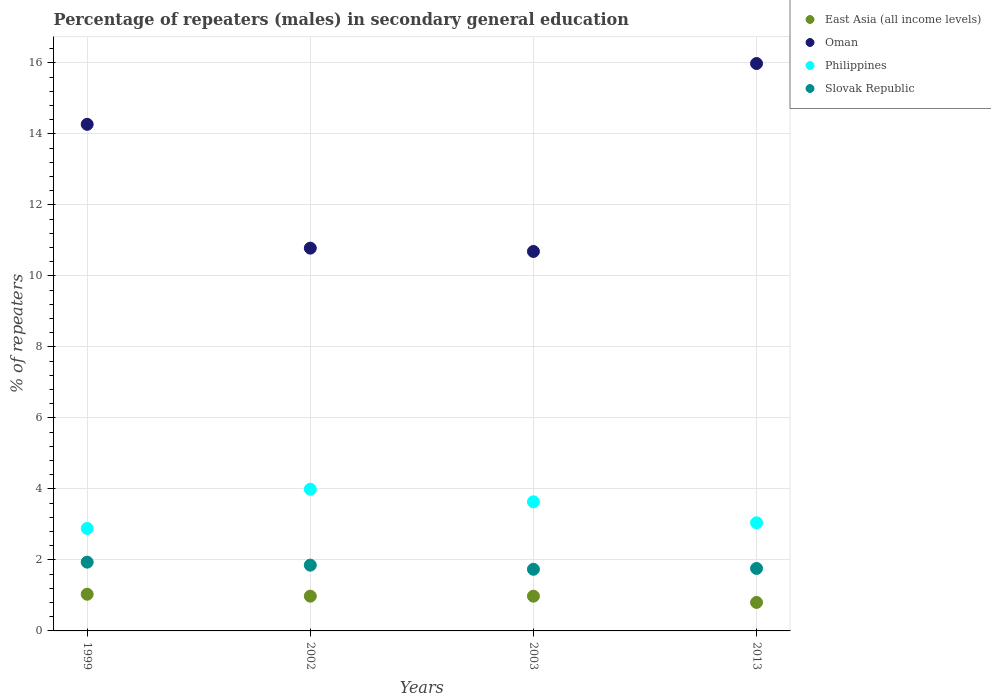How many different coloured dotlines are there?
Provide a short and direct response. 4. What is the percentage of male repeaters in Oman in 2013?
Provide a short and direct response. 15.98. Across all years, what is the maximum percentage of male repeaters in East Asia (all income levels)?
Provide a short and direct response. 1.03. Across all years, what is the minimum percentage of male repeaters in Philippines?
Ensure brevity in your answer.  2.89. In which year was the percentage of male repeaters in Oman maximum?
Your response must be concise. 2013. What is the total percentage of male repeaters in East Asia (all income levels) in the graph?
Your response must be concise. 3.79. What is the difference between the percentage of male repeaters in Oman in 1999 and that in 2013?
Provide a succinct answer. -1.71. What is the difference between the percentage of male repeaters in Philippines in 2003 and the percentage of male repeaters in Oman in 2013?
Your answer should be very brief. -12.34. What is the average percentage of male repeaters in Slovak Republic per year?
Give a very brief answer. 1.82. In the year 1999, what is the difference between the percentage of male repeaters in Philippines and percentage of male repeaters in Oman?
Offer a terse response. -11.38. In how many years, is the percentage of male repeaters in Oman greater than 3.6 %?
Ensure brevity in your answer.  4. What is the ratio of the percentage of male repeaters in Philippines in 2002 to that in 2013?
Offer a terse response. 1.31. Is the percentage of male repeaters in Philippines in 1999 less than that in 2013?
Keep it short and to the point. Yes. Is the difference between the percentage of male repeaters in Philippines in 2002 and 2003 greater than the difference between the percentage of male repeaters in Oman in 2002 and 2003?
Keep it short and to the point. Yes. What is the difference between the highest and the second highest percentage of male repeaters in Philippines?
Make the answer very short. 0.36. What is the difference between the highest and the lowest percentage of male repeaters in Oman?
Provide a short and direct response. 5.29. Is the sum of the percentage of male repeaters in Oman in 1999 and 2002 greater than the maximum percentage of male repeaters in Philippines across all years?
Offer a terse response. Yes. Is it the case that in every year, the sum of the percentage of male repeaters in Philippines and percentage of male repeaters in Oman  is greater than the sum of percentage of male repeaters in East Asia (all income levels) and percentage of male repeaters in Slovak Republic?
Provide a short and direct response. No. Is the percentage of male repeaters in East Asia (all income levels) strictly less than the percentage of male repeaters in Philippines over the years?
Provide a succinct answer. Yes. What is the difference between two consecutive major ticks on the Y-axis?
Offer a terse response. 2. Does the graph contain any zero values?
Your response must be concise. No. How many legend labels are there?
Offer a terse response. 4. What is the title of the graph?
Offer a very short reply. Percentage of repeaters (males) in secondary general education. Does "Albania" appear as one of the legend labels in the graph?
Your response must be concise. No. What is the label or title of the X-axis?
Provide a short and direct response. Years. What is the label or title of the Y-axis?
Offer a terse response. % of repeaters. What is the % of repeaters in East Asia (all income levels) in 1999?
Your answer should be compact. 1.03. What is the % of repeaters in Oman in 1999?
Your response must be concise. 14.27. What is the % of repeaters of Philippines in 1999?
Give a very brief answer. 2.89. What is the % of repeaters of Slovak Republic in 1999?
Ensure brevity in your answer.  1.94. What is the % of repeaters in East Asia (all income levels) in 2002?
Your response must be concise. 0.98. What is the % of repeaters of Oman in 2002?
Provide a succinct answer. 10.78. What is the % of repeaters of Philippines in 2002?
Make the answer very short. 3.99. What is the % of repeaters of Slovak Republic in 2002?
Give a very brief answer. 1.85. What is the % of repeaters of East Asia (all income levels) in 2003?
Your answer should be very brief. 0.98. What is the % of repeaters of Oman in 2003?
Provide a short and direct response. 10.69. What is the % of repeaters of Philippines in 2003?
Give a very brief answer. 3.64. What is the % of repeaters of Slovak Republic in 2003?
Give a very brief answer. 1.74. What is the % of repeaters of East Asia (all income levels) in 2013?
Your response must be concise. 0.8. What is the % of repeaters in Oman in 2013?
Ensure brevity in your answer.  15.98. What is the % of repeaters of Philippines in 2013?
Keep it short and to the point. 3.04. What is the % of repeaters in Slovak Republic in 2013?
Your answer should be very brief. 1.76. Across all years, what is the maximum % of repeaters in East Asia (all income levels)?
Offer a very short reply. 1.03. Across all years, what is the maximum % of repeaters in Oman?
Keep it short and to the point. 15.98. Across all years, what is the maximum % of repeaters in Philippines?
Make the answer very short. 3.99. Across all years, what is the maximum % of repeaters in Slovak Republic?
Make the answer very short. 1.94. Across all years, what is the minimum % of repeaters in East Asia (all income levels)?
Your answer should be very brief. 0.8. Across all years, what is the minimum % of repeaters in Oman?
Offer a very short reply. 10.69. Across all years, what is the minimum % of repeaters of Philippines?
Offer a very short reply. 2.89. Across all years, what is the minimum % of repeaters of Slovak Republic?
Offer a terse response. 1.74. What is the total % of repeaters in East Asia (all income levels) in the graph?
Provide a succinct answer. 3.79. What is the total % of repeaters in Oman in the graph?
Your answer should be compact. 51.71. What is the total % of repeaters in Philippines in the graph?
Your answer should be very brief. 13.56. What is the total % of repeaters in Slovak Republic in the graph?
Keep it short and to the point. 7.28. What is the difference between the % of repeaters of East Asia (all income levels) in 1999 and that in 2002?
Your response must be concise. 0.05. What is the difference between the % of repeaters in Oman in 1999 and that in 2002?
Give a very brief answer. 3.49. What is the difference between the % of repeaters of Philippines in 1999 and that in 2002?
Make the answer very short. -1.1. What is the difference between the % of repeaters of Slovak Republic in 1999 and that in 2002?
Give a very brief answer. 0.09. What is the difference between the % of repeaters of East Asia (all income levels) in 1999 and that in 2003?
Ensure brevity in your answer.  0.05. What is the difference between the % of repeaters in Oman in 1999 and that in 2003?
Offer a very short reply. 3.58. What is the difference between the % of repeaters of Philippines in 1999 and that in 2003?
Your answer should be very brief. -0.75. What is the difference between the % of repeaters of Slovak Republic in 1999 and that in 2003?
Make the answer very short. 0.2. What is the difference between the % of repeaters of East Asia (all income levels) in 1999 and that in 2013?
Make the answer very short. 0.23. What is the difference between the % of repeaters of Oman in 1999 and that in 2013?
Your response must be concise. -1.71. What is the difference between the % of repeaters of Philippines in 1999 and that in 2013?
Keep it short and to the point. -0.16. What is the difference between the % of repeaters in Slovak Republic in 1999 and that in 2013?
Provide a succinct answer. 0.18. What is the difference between the % of repeaters of Oman in 2002 and that in 2003?
Offer a very short reply. 0.09. What is the difference between the % of repeaters in Philippines in 2002 and that in 2003?
Provide a short and direct response. 0.36. What is the difference between the % of repeaters of Slovak Republic in 2002 and that in 2003?
Keep it short and to the point. 0.12. What is the difference between the % of repeaters in East Asia (all income levels) in 2002 and that in 2013?
Your answer should be compact. 0.18. What is the difference between the % of repeaters of Oman in 2002 and that in 2013?
Your answer should be very brief. -5.2. What is the difference between the % of repeaters of Philippines in 2002 and that in 2013?
Your answer should be very brief. 0.95. What is the difference between the % of repeaters in Slovak Republic in 2002 and that in 2013?
Your answer should be compact. 0.09. What is the difference between the % of repeaters of East Asia (all income levels) in 2003 and that in 2013?
Offer a very short reply. 0.18. What is the difference between the % of repeaters of Oman in 2003 and that in 2013?
Ensure brevity in your answer.  -5.29. What is the difference between the % of repeaters of Philippines in 2003 and that in 2013?
Ensure brevity in your answer.  0.59. What is the difference between the % of repeaters of Slovak Republic in 2003 and that in 2013?
Ensure brevity in your answer.  -0.02. What is the difference between the % of repeaters in East Asia (all income levels) in 1999 and the % of repeaters in Oman in 2002?
Your answer should be very brief. -9.75. What is the difference between the % of repeaters of East Asia (all income levels) in 1999 and the % of repeaters of Philippines in 2002?
Keep it short and to the point. -2.96. What is the difference between the % of repeaters of East Asia (all income levels) in 1999 and the % of repeaters of Slovak Republic in 2002?
Your response must be concise. -0.82. What is the difference between the % of repeaters in Oman in 1999 and the % of repeaters in Philippines in 2002?
Your response must be concise. 10.28. What is the difference between the % of repeaters in Oman in 1999 and the % of repeaters in Slovak Republic in 2002?
Keep it short and to the point. 12.41. What is the difference between the % of repeaters of Philippines in 1999 and the % of repeaters of Slovak Republic in 2002?
Keep it short and to the point. 1.03. What is the difference between the % of repeaters in East Asia (all income levels) in 1999 and the % of repeaters in Oman in 2003?
Give a very brief answer. -9.65. What is the difference between the % of repeaters of East Asia (all income levels) in 1999 and the % of repeaters of Philippines in 2003?
Offer a terse response. -2.6. What is the difference between the % of repeaters in East Asia (all income levels) in 1999 and the % of repeaters in Slovak Republic in 2003?
Provide a succinct answer. -0.7. What is the difference between the % of repeaters in Oman in 1999 and the % of repeaters in Philippines in 2003?
Your answer should be very brief. 10.63. What is the difference between the % of repeaters of Oman in 1999 and the % of repeaters of Slovak Republic in 2003?
Give a very brief answer. 12.53. What is the difference between the % of repeaters of Philippines in 1999 and the % of repeaters of Slovak Republic in 2003?
Your answer should be compact. 1.15. What is the difference between the % of repeaters in East Asia (all income levels) in 1999 and the % of repeaters in Oman in 2013?
Offer a very short reply. -14.95. What is the difference between the % of repeaters of East Asia (all income levels) in 1999 and the % of repeaters of Philippines in 2013?
Provide a succinct answer. -2.01. What is the difference between the % of repeaters in East Asia (all income levels) in 1999 and the % of repeaters in Slovak Republic in 2013?
Your response must be concise. -0.73. What is the difference between the % of repeaters in Oman in 1999 and the % of repeaters in Philippines in 2013?
Your response must be concise. 11.22. What is the difference between the % of repeaters of Oman in 1999 and the % of repeaters of Slovak Republic in 2013?
Your response must be concise. 12.51. What is the difference between the % of repeaters in Philippines in 1999 and the % of repeaters in Slovak Republic in 2013?
Your answer should be compact. 1.13. What is the difference between the % of repeaters in East Asia (all income levels) in 2002 and the % of repeaters in Oman in 2003?
Give a very brief answer. -9.71. What is the difference between the % of repeaters of East Asia (all income levels) in 2002 and the % of repeaters of Philippines in 2003?
Your response must be concise. -2.66. What is the difference between the % of repeaters in East Asia (all income levels) in 2002 and the % of repeaters in Slovak Republic in 2003?
Offer a very short reply. -0.76. What is the difference between the % of repeaters of Oman in 2002 and the % of repeaters of Philippines in 2003?
Provide a succinct answer. 7.15. What is the difference between the % of repeaters in Oman in 2002 and the % of repeaters in Slovak Republic in 2003?
Offer a very short reply. 9.04. What is the difference between the % of repeaters of Philippines in 2002 and the % of repeaters of Slovak Republic in 2003?
Offer a terse response. 2.25. What is the difference between the % of repeaters in East Asia (all income levels) in 2002 and the % of repeaters in Oman in 2013?
Give a very brief answer. -15. What is the difference between the % of repeaters in East Asia (all income levels) in 2002 and the % of repeaters in Philippines in 2013?
Provide a short and direct response. -2.07. What is the difference between the % of repeaters in East Asia (all income levels) in 2002 and the % of repeaters in Slovak Republic in 2013?
Make the answer very short. -0.78. What is the difference between the % of repeaters in Oman in 2002 and the % of repeaters in Philippines in 2013?
Ensure brevity in your answer.  7.74. What is the difference between the % of repeaters of Oman in 2002 and the % of repeaters of Slovak Republic in 2013?
Your answer should be compact. 9.02. What is the difference between the % of repeaters of Philippines in 2002 and the % of repeaters of Slovak Republic in 2013?
Give a very brief answer. 2.23. What is the difference between the % of repeaters of East Asia (all income levels) in 2003 and the % of repeaters of Oman in 2013?
Make the answer very short. -15. What is the difference between the % of repeaters in East Asia (all income levels) in 2003 and the % of repeaters in Philippines in 2013?
Give a very brief answer. -2.07. What is the difference between the % of repeaters in East Asia (all income levels) in 2003 and the % of repeaters in Slovak Republic in 2013?
Give a very brief answer. -0.78. What is the difference between the % of repeaters of Oman in 2003 and the % of repeaters of Philippines in 2013?
Offer a very short reply. 7.64. What is the difference between the % of repeaters of Oman in 2003 and the % of repeaters of Slovak Republic in 2013?
Offer a terse response. 8.93. What is the difference between the % of repeaters of Philippines in 2003 and the % of repeaters of Slovak Republic in 2013?
Provide a short and direct response. 1.88. What is the average % of repeaters in East Asia (all income levels) per year?
Ensure brevity in your answer.  0.95. What is the average % of repeaters in Oman per year?
Offer a very short reply. 12.93. What is the average % of repeaters of Philippines per year?
Your answer should be very brief. 3.39. What is the average % of repeaters of Slovak Republic per year?
Provide a short and direct response. 1.82. In the year 1999, what is the difference between the % of repeaters in East Asia (all income levels) and % of repeaters in Oman?
Ensure brevity in your answer.  -13.23. In the year 1999, what is the difference between the % of repeaters of East Asia (all income levels) and % of repeaters of Philippines?
Provide a succinct answer. -1.85. In the year 1999, what is the difference between the % of repeaters of East Asia (all income levels) and % of repeaters of Slovak Republic?
Keep it short and to the point. -0.9. In the year 1999, what is the difference between the % of repeaters of Oman and % of repeaters of Philippines?
Offer a very short reply. 11.38. In the year 1999, what is the difference between the % of repeaters in Oman and % of repeaters in Slovak Republic?
Your response must be concise. 12.33. In the year 1999, what is the difference between the % of repeaters in Philippines and % of repeaters in Slovak Republic?
Keep it short and to the point. 0.95. In the year 2002, what is the difference between the % of repeaters in East Asia (all income levels) and % of repeaters in Oman?
Your answer should be compact. -9.8. In the year 2002, what is the difference between the % of repeaters in East Asia (all income levels) and % of repeaters in Philippines?
Ensure brevity in your answer.  -3.01. In the year 2002, what is the difference between the % of repeaters in East Asia (all income levels) and % of repeaters in Slovak Republic?
Your answer should be compact. -0.87. In the year 2002, what is the difference between the % of repeaters in Oman and % of repeaters in Philippines?
Your answer should be compact. 6.79. In the year 2002, what is the difference between the % of repeaters of Oman and % of repeaters of Slovak Republic?
Your answer should be very brief. 8.93. In the year 2002, what is the difference between the % of repeaters in Philippines and % of repeaters in Slovak Republic?
Ensure brevity in your answer.  2.14. In the year 2003, what is the difference between the % of repeaters in East Asia (all income levels) and % of repeaters in Oman?
Ensure brevity in your answer.  -9.71. In the year 2003, what is the difference between the % of repeaters of East Asia (all income levels) and % of repeaters of Philippines?
Offer a very short reply. -2.66. In the year 2003, what is the difference between the % of repeaters of East Asia (all income levels) and % of repeaters of Slovak Republic?
Your answer should be very brief. -0.76. In the year 2003, what is the difference between the % of repeaters in Oman and % of repeaters in Philippines?
Ensure brevity in your answer.  7.05. In the year 2003, what is the difference between the % of repeaters in Oman and % of repeaters in Slovak Republic?
Your response must be concise. 8.95. In the year 2003, what is the difference between the % of repeaters of Philippines and % of repeaters of Slovak Republic?
Provide a short and direct response. 1.9. In the year 2013, what is the difference between the % of repeaters of East Asia (all income levels) and % of repeaters of Oman?
Your response must be concise. -15.18. In the year 2013, what is the difference between the % of repeaters in East Asia (all income levels) and % of repeaters in Philippines?
Your response must be concise. -2.24. In the year 2013, what is the difference between the % of repeaters in East Asia (all income levels) and % of repeaters in Slovak Republic?
Provide a succinct answer. -0.96. In the year 2013, what is the difference between the % of repeaters of Oman and % of repeaters of Philippines?
Your answer should be compact. 12.94. In the year 2013, what is the difference between the % of repeaters of Oman and % of repeaters of Slovak Republic?
Your response must be concise. 14.22. In the year 2013, what is the difference between the % of repeaters of Philippines and % of repeaters of Slovak Republic?
Make the answer very short. 1.29. What is the ratio of the % of repeaters of East Asia (all income levels) in 1999 to that in 2002?
Keep it short and to the point. 1.06. What is the ratio of the % of repeaters of Oman in 1999 to that in 2002?
Offer a terse response. 1.32. What is the ratio of the % of repeaters in Philippines in 1999 to that in 2002?
Your answer should be very brief. 0.72. What is the ratio of the % of repeaters in Slovak Republic in 1999 to that in 2002?
Your response must be concise. 1.05. What is the ratio of the % of repeaters in East Asia (all income levels) in 1999 to that in 2003?
Keep it short and to the point. 1.06. What is the ratio of the % of repeaters in Oman in 1999 to that in 2003?
Offer a very short reply. 1.33. What is the ratio of the % of repeaters of Philippines in 1999 to that in 2003?
Keep it short and to the point. 0.79. What is the ratio of the % of repeaters of Slovak Republic in 1999 to that in 2003?
Provide a short and direct response. 1.12. What is the ratio of the % of repeaters of East Asia (all income levels) in 1999 to that in 2013?
Ensure brevity in your answer.  1.29. What is the ratio of the % of repeaters of Oman in 1999 to that in 2013?
Keep it short and to the point. 0.89. What is the ratio of the % of repeaters in Philippines in 1999 to that in 2013?
Your response must be concise. 0.95. What is the ratio of the % of repeaters of Slovak Republic in 1999 to that in 2013?
Give a very brief answer. 1.1. What is the ratio of the % of repeaters of East Asia (all income levels) in 2002 to that in 2003?
Keep it short and to the point. 1. What is the ratio of the % of repeaters of Oman in 2002 to that in 2003?
Your answer should be very brief. 1.01. What is the ratio of the % of repeaters of Philippines in 2002 to that in 2003?
Your response must be concise. 1.1. What is the ratio of the % of repeaters in Slovak Republic in 2002 to that in 2003?
Give a very brief answer. 1.07. What is the ratio of the % of repeaters of East Asia (all income levels) in 2002 to that in 2013?
Provide a succinct answer. 1.22. What is the ratio of the % of repeaters in Oman in 2002 to that in 2013?
Provide a succinct answer. 0.67. What is the ratio of the % of repeaters in Philippines in 2002 to that in 2013?
Your answer should be very brief. 1.31. What is the ratio of the % of repeaters of Slovak Republic in 2002 to that in 2013?
Make the answer very short. 1.05. What is the ratio of the % of repeaters in East Asia (all income levels) in 2003 to that in 2013?
Offer a terse response. 1.22. What is the ratio of the % of repeaters of Oman in 2003 to that in 2013?
Your answer should be very brief. 0.67. What is the ratio of the % of repeaters in Philippines in 2003 to that in 2013?
Your answer should be very brief. 1.19. What is the ratio of the % of repeaters in Slovak Republic in 2003 to that in 2013?
Ensure brevity in your answer.  0.99. What is the difference between the highest and the second highest % of repeaters in East Asia (all income levels)?
Your answer should be compact. 0.05. What is the difference between the highest and the second highest % of repeaters of Oman?
Your response must be concise. 1.71. What is the difference between the highest and the second highest % of repeaters of Philippines?
Provide a succinct answer. 0.36. What is the difference between the highest and the second highest % of repeaters of Slovak Republic?
Your answer should be compact. 0.09. What is the difference between the highest and the lowest % of repeaters in East Asia (all income levels)?
Your answer should be very brief. 0.23. What is the difference between the highest and the lowest % of repeaters of Oman?
Offer a very short reply. 5.29. What is the difference between the highest and the lowest % of repeaters of Philippines?
Your response must be concise. 1.1. What is the difference between the highest and the lowest % of repeaters in Slovak Republic?
Offer a very short reply. 0.2. 